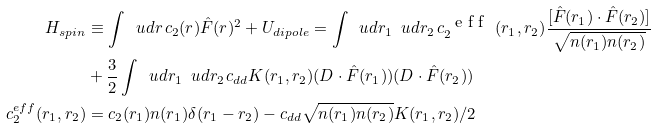<formula> <loc_0><loc_0><loc_500><loc_500>H _ { s p i n } & \equiv \int \, \ u d r \, c _ { 2 } ( r ) \hat { F } ( r ) ^ { 2 } + U _ { d i p o l e } = \int \, \ u d r _ { 1 } \, \ u d r _ { 2 } \, c _ { 2 } ^ { \mbox { { e f f } } } ( r _ { 1 } , r _ { 2 } ) \frac { [ \hat { F } ( r _ { 1 } ) \cdot \hat { F } ( r _ { 2 } ) ] } { \sqrt { n ( r _ { 1 } ) n ( r _ { 2 } ) } } \\ & + \frac { 3 } { 2 } \int \, \ u d r _ { 1 } \, \ u d r _ { 2 } \, c _ { d d } K ( r _ { 1 } , r _ { 2 } ) ( D \cdot \hat { F } ( r _ { 1 } ) ) ( D \cdot \hat { F } ( r _ { 2 } ) ) \\ c _ { 2 } ^ { e f f } ( r _ { 1 } , r _ { 2 } ) & = c _ { 2 } ( r _ { 1 } ) n ( r _ { 1 } ) \delta ( r _ { 1 } - r _ { 2 } ) - c _ { d d } \sqrt { n ( r _ { 1 } ) n ( r _ { 2 } ) } K ( r _ { 1 } , r _ { 2 } ) / 2</formula> 